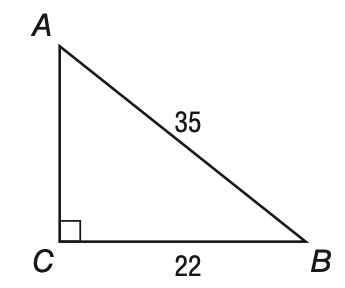Question: In right triangle A B C shown below, what is the measure of \angle A to the nearest tenth of a degree?
Choices:
A. 32.2
B. 38.9
C. 51.1
D. 57.8
Answer with the letter. Answer: B 